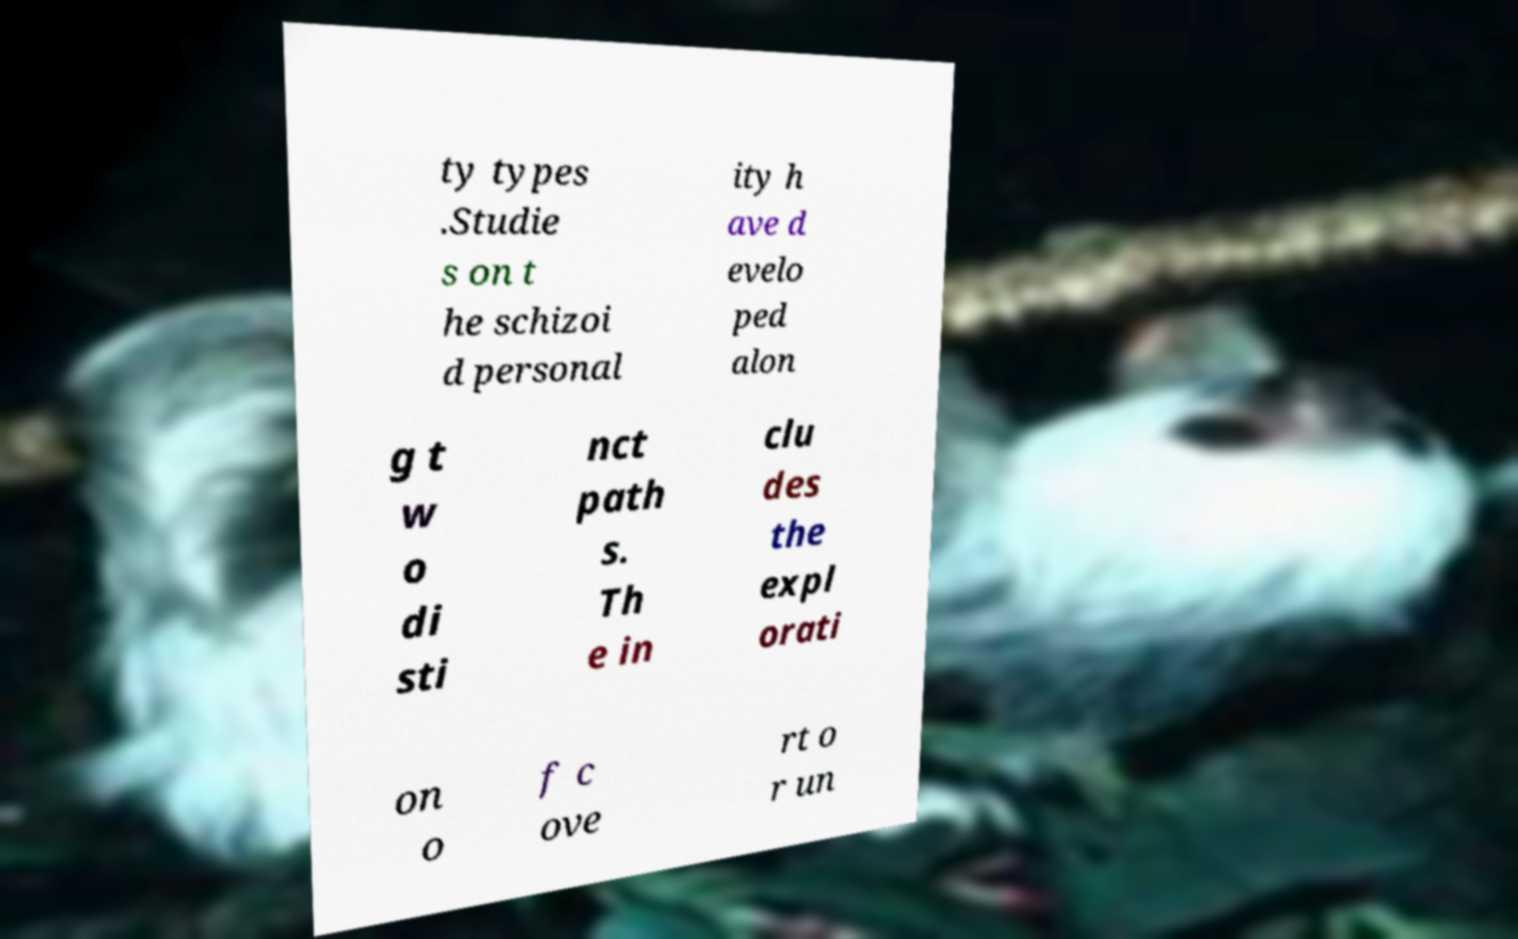What messages or text are displayed in this image? I need them in a readable, typed format. ty types .Studie s on t he schizoi d personal ity h ave d evelo ped alon g t w o di sti nct path s. Th e in clu des the expl orati on o f c ove rt o r un 